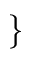<formula> <loc_0><loc_0><loc_500><loc_500>\}</formula> 